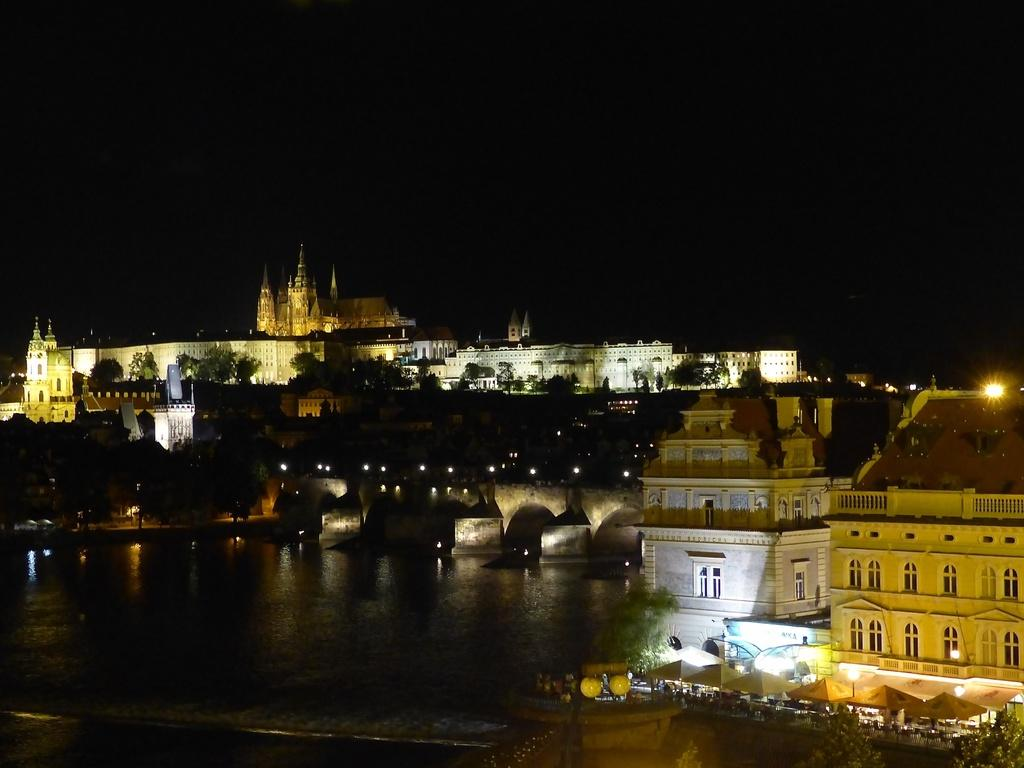Where was the image taken? The image was clicked outside. What can be seen in the middle of the image? There are buildings and trees in the middle of the image. What is at the bottom of the image? There is water at the bottom of the image. What is visible at the top of the image? The sky is visible at the top of the image. What type of house does the grandmother live in, as seen in the image? There is no mention of a grandmother or a house in the image; it features buildings, trees, water, and the sky. 